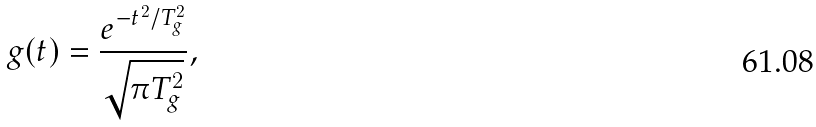Convert formula to latex. <formula><loc_0><loc_0><loc_500><loc_500>g ( t ) = \frac { e ^ { - t ^ { 2 } / T _ { g } ^ { 2 } } } { \sqrt { \pi T _ { g } ^ { 2 } } } ,</formula> 